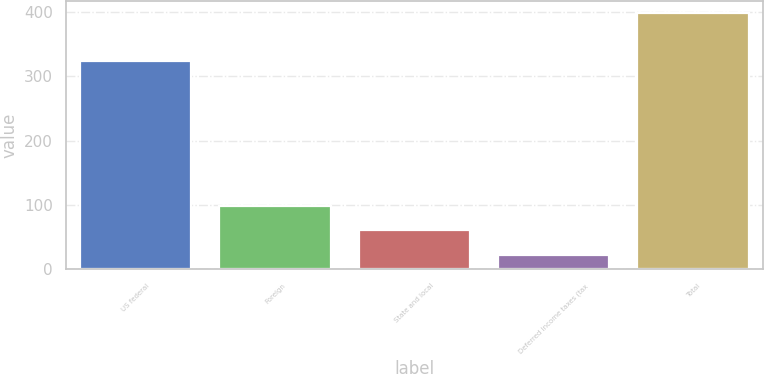Convert chart to OTSL. <chart><loc_0><loc_0><loc_500><loc_500><bar_chart><fcel>US federal<fcel>Foreign<fcel>State and local<fcel>Deferred income taxes (tax<fcel>Total<nl><fcel>323.4<fcel>98.12<fcel>60.66<fcel>23.2<fcel>397.8<nl></chart> 